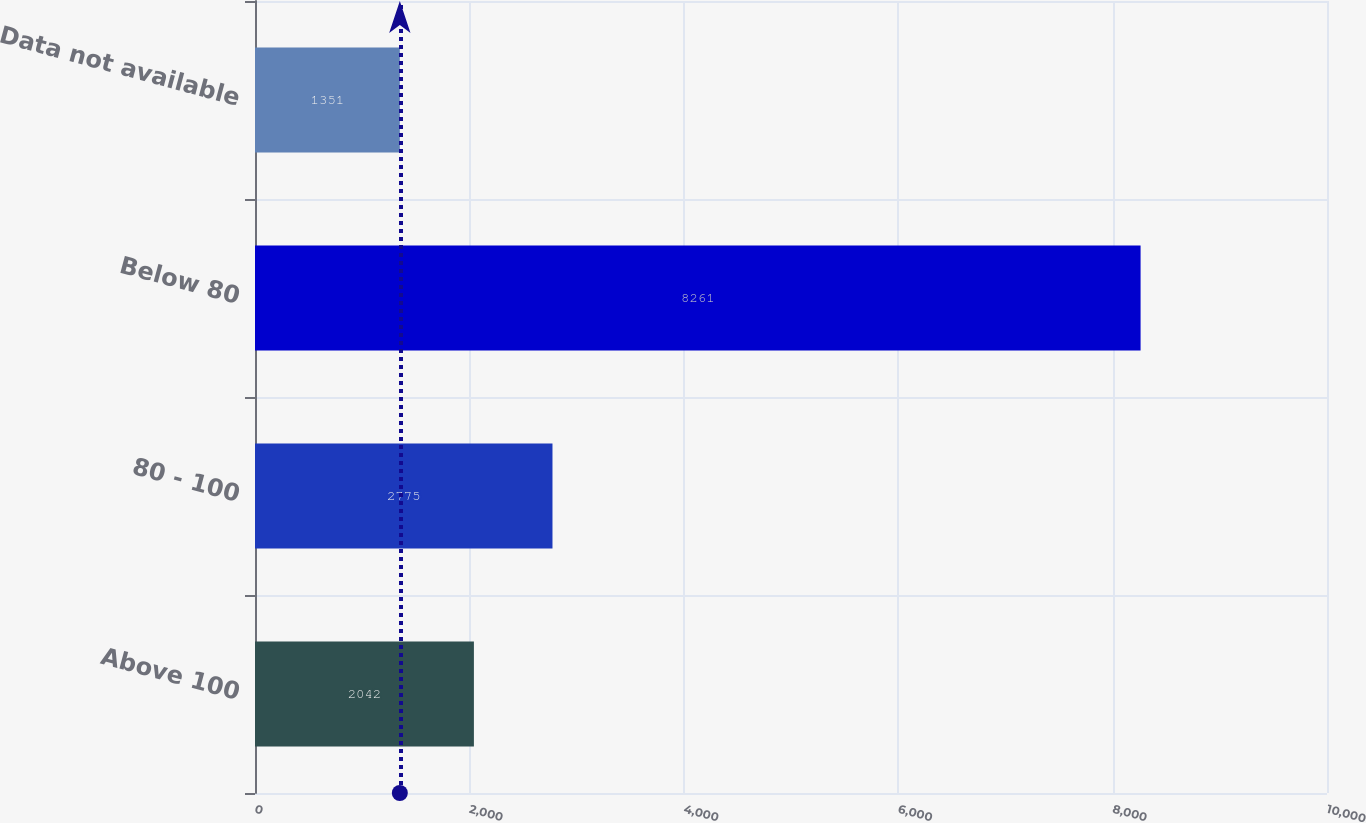Convert chart. <chart><loc_0><loc_0><loc_500><loc_500><bar_chart><fcel>Above 100<fcel>80 - 100<fcel>Below 80<fcel>Data not available<nl><fcel>2042<fcel>2775<fcel>8261<fcel>1351<nl></chart> 